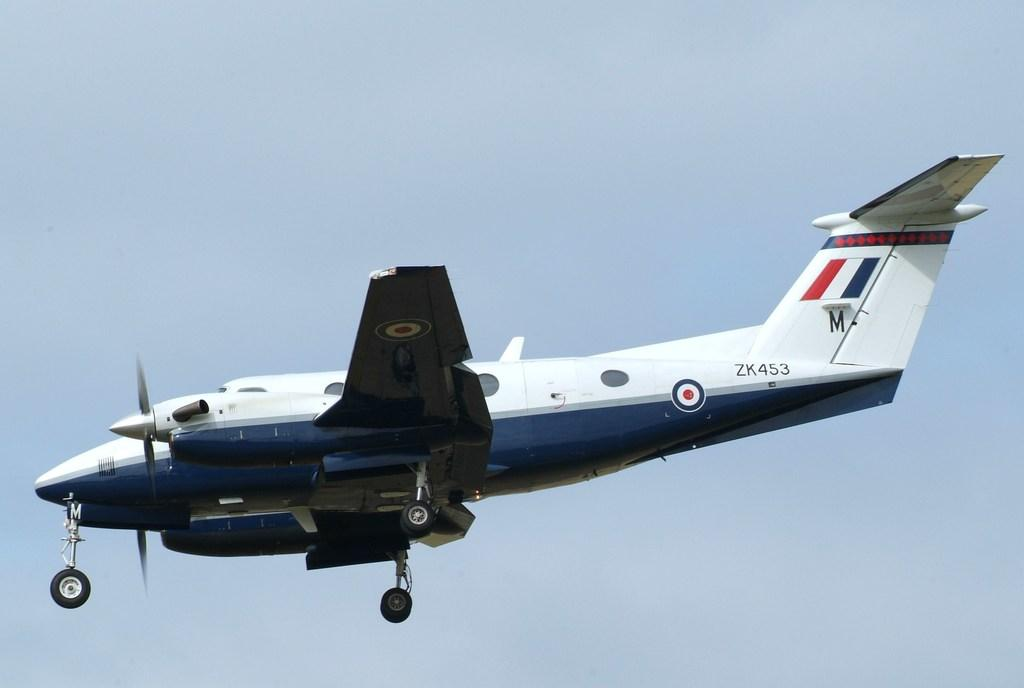<image>
Present a compact description of the photo's key features. A blue and white plane with the I.D. ZK453 on the side. 